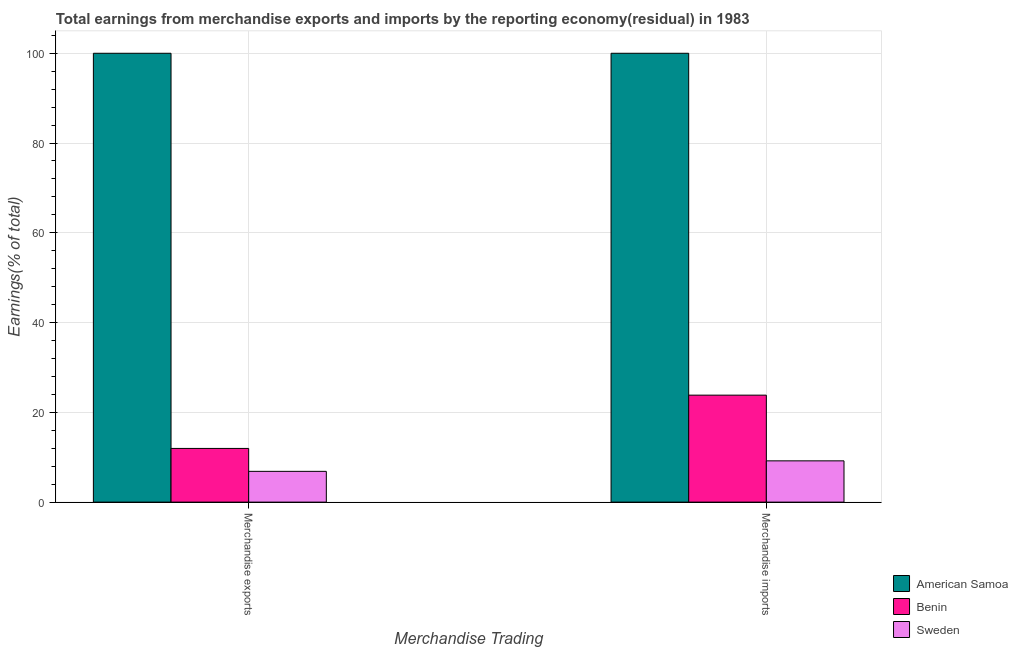How many groups of bars are there?
Keep it short and to the point. 2. Are the number of bars per tick equal to the number of legend labels?
Offer a very short reply. Yes. Are the number of bars on each tick of the X-axis equal?
Your answer should be compact. Yes. How many bars are there on the 2nd tick from the right?
Your answer should be very brief. 3. What is the earnings from merchandise exports in Sweden?
Your answer should be compact. 6.85. Across all countries, what is the maximum earnings from merchandise exports?
Your answer should be very brief. 100. Across all countries, what is the minimum earnings from merchandise imports?
Your answer should be compact. 9.2. In which country was the earnings from merchandise exports maximum?
Provide a succinct answer. American Samoa. What is the total earnings from merchandise imports in the graph?
Make the answer very short. 133.03. What is the difference between the earnings from merchandise imports in American Samoa and that in Sweden?
Your answer should be compact. 90.8. What is the difference between the earnings from merchandise exports in American Samoa and the earnings from merchandise imports in Benin?
Your answer should be very brief. 76.17. What is the average earnings from merchandise exports per country?
Your response must be concise. 39.61. What is the difference between the earnings from merchandise exports and earnings from merchandise imports in American Samoa?
Give a very brief answer. 0. In how many countries, is the earnings from merchandise imports greater than 88 %?
Provide a succinct answer. 1. What is the ratio of the earnings from merchandise imports in American Samoa to that in Sweden?
Your response must be concise. 10.87. What does the 1st bar from the left in Merchandise imports represents?
Keep it short and to the point. American Samoa. What does the 1st bar from the right in Merchandise exports represents?
Provide a short and direct response. Sweden. How many countries are there in the graph?
Offer a very short reply. 3. Does the graph contain grids?
Provide a short and direct response. Yes. Where does the legend appear in the graph?
Make the answer very short. Bottom right. What is the title of the graph?
Make the answer very short. Total earnings from merchandise exports and imports by the reporting economy(residual) in 1983. What is the label or title of the X-axis?
Provide a succinct answer. Merchandise Trading. What is the label or title of the Y-axis?
Offer a terse response. Earnings(% of total). What is the Earnings(% of total) in American Samoa in Merchandise exports?
Offer a very short reply. 100. What is the Earnings(% of total) in Benin in Merchandise exports?
Ensure brevity in your answer.  11.96. What is the Earnings(% of total) of Sweden in Merchandise exports?
Your answer should be compact. 6.85. What is the Earnings(% of total) in Benin in Merchandise imports?
Make the answer very short. 23.83. What is the Earnings(% of total) of Sweden in Merchandise imports?
Make the answer very short. 9.2. Across all Merchandise Trading, what is the maximum Earnings(% of total) in Benin?
Offer a very short reply. 23.83. Across all Merchandise Trading, what is the maximum Earnings(% of total) of Sweden?
Keep it short and to the point. 9.2. Across all Merchandise Trading, what is the minimum Earnings(% of total) of American Samoa?
Offer a terse response. 100. Across all Merchandise Trading, what is the minimum Earnings(% of total) in Benin?
Keep it short and to the point. 11.96. Across all Merchandise Trading, what is the minimum Earnings(% of total) in Sweden?
Keep it short and to the point. 6.85. What is the total Earnings(% of total) in American Samoa in the graph?
Your response must be concise. 200. What is the total Earnings(% of total) of Benin in the graph?
Your answer should be very brief. 35.79. What is the total Earnings(% of total) of Sweden in the graph?
Your answer should be very brief. 16.05. What is the difference between the Earnings(% of total) in American Samoa in Merchandise exports and that in Merchandise imports?
Make the answer very short. 0. What is the difference between the Earnings(% of total) in Benin in Merchandise exports and that in Merchandise imports?
Give a very brief answer. -11.87. What is the difference between the Earnings(% of total) in Sweden in Merchandise exports and that in Merchandise imports?
Ensure brevity in your answer.  -2.34. What is the difference between the Earnings(% of total) of American Samoa in Merchandise exports and the Earnings(% of total) of Benin in Merchandise imports?
Provide a succinct answer. 76.17. What is the difference between the Earnings(% of total) of American Samoa in Merchandise exports and the Earnings(% of total) of Sweden in Merchandise imports?
Provide a succinct answer. 90.8. What is the difference between the Earnings(% of total) of Benin in Merchandise exports and the Earnings(% of total) of Sweden in Merchandise imports?
Offer a very short reply. 2.76. What is the average Earnings(% of total) of Benin per Merchandise Trading?
Make the answer very short. 17.9. What is the average Earnings(% of total) in Sweden per Merchandise Trading?
Your answer should be very brief. 8.03. What is the difference between the Earnings(% of total) in American Samoa and Earnings(% of total) in Benin in Merchandise exports?
Keep it short and to the point. 88.04. What is the difference between the Earnings(% of total) of American Samoa and Earnings(% of total) of Sweden in Merchandise exports?
Provide a short and direct response. 93.15. What is the difference between the Earnings(% of total) in Benin and Earnings(% of total) in Sweden in Merchandise exports?
Your answer should be compact. 5.11. What is the difference between the Earnings(% of total) in American Samoa and Earnings(% of total) in Benin in Merchandise imports?
Offer a terse response. 76.17. What is the difference between the Earnings(% of total) in American Samoa and Earnings(% of total) in Sweden in Merchandise imports?
Keep it short and to the point. 90.8. What is the difference between the Earnings(% of total) in Benin and Earnings(% of total) in Sweden in Merchandise imports?
Your answer should be very brief. 14.64. What is the ratio of the Earnings(% of total) in American Samoa in Merchandise exports to that in Merchandise imports?
Provide a short and direct response. 1. What is the ratio of the Earnings(% of total) of Benin in Merchandise exports to that in Merchandise imports?
Keep it short and to the point. 0.5. What is the ratio of the Earnings(% of total) of Sweden in Merchandise exports to that in Merchandise imports?
Keep it short and to the point. 0.75. What is the difference between the highest and the second highest Earnings(% of total) in American Samoa?
Your response must be concise. 0. What is the difference between the highest and the second highest Earnings(% of total) in Benin?
Provide a short and direct response. 11.87. What is the difference between the highest and the second highest Earnings(% of total) in Sweden?
Provide a short and direct response. 2.34. What is the difference between the highest and the lowest Earnings(% of total) in Benin?
Offer a terse response. 11.87. What is the difference between the highest and the lowest Earnings(% of total) in Sweden?
Provide a succinct answer. 2.34. 